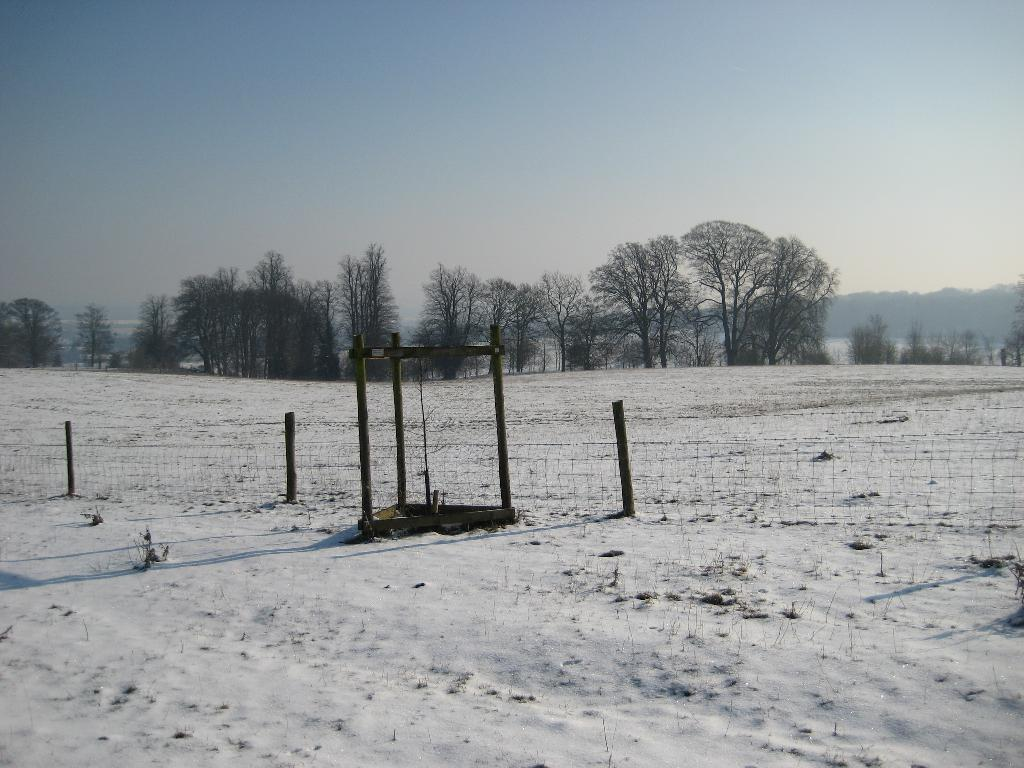What is the primary characteristic of the land in the image? The land in the image is covered with snow. What type of structure can be seen in the image? There is a fencing in the image. What can be seen in the distance in the image? There are many trees in the background of the image, and mountains are visible behind the trees. What type of calculator is being used by the trees in the image? There is no calculator present in the image, as it features a snow-covered landscape with trees and mountains in the background. 